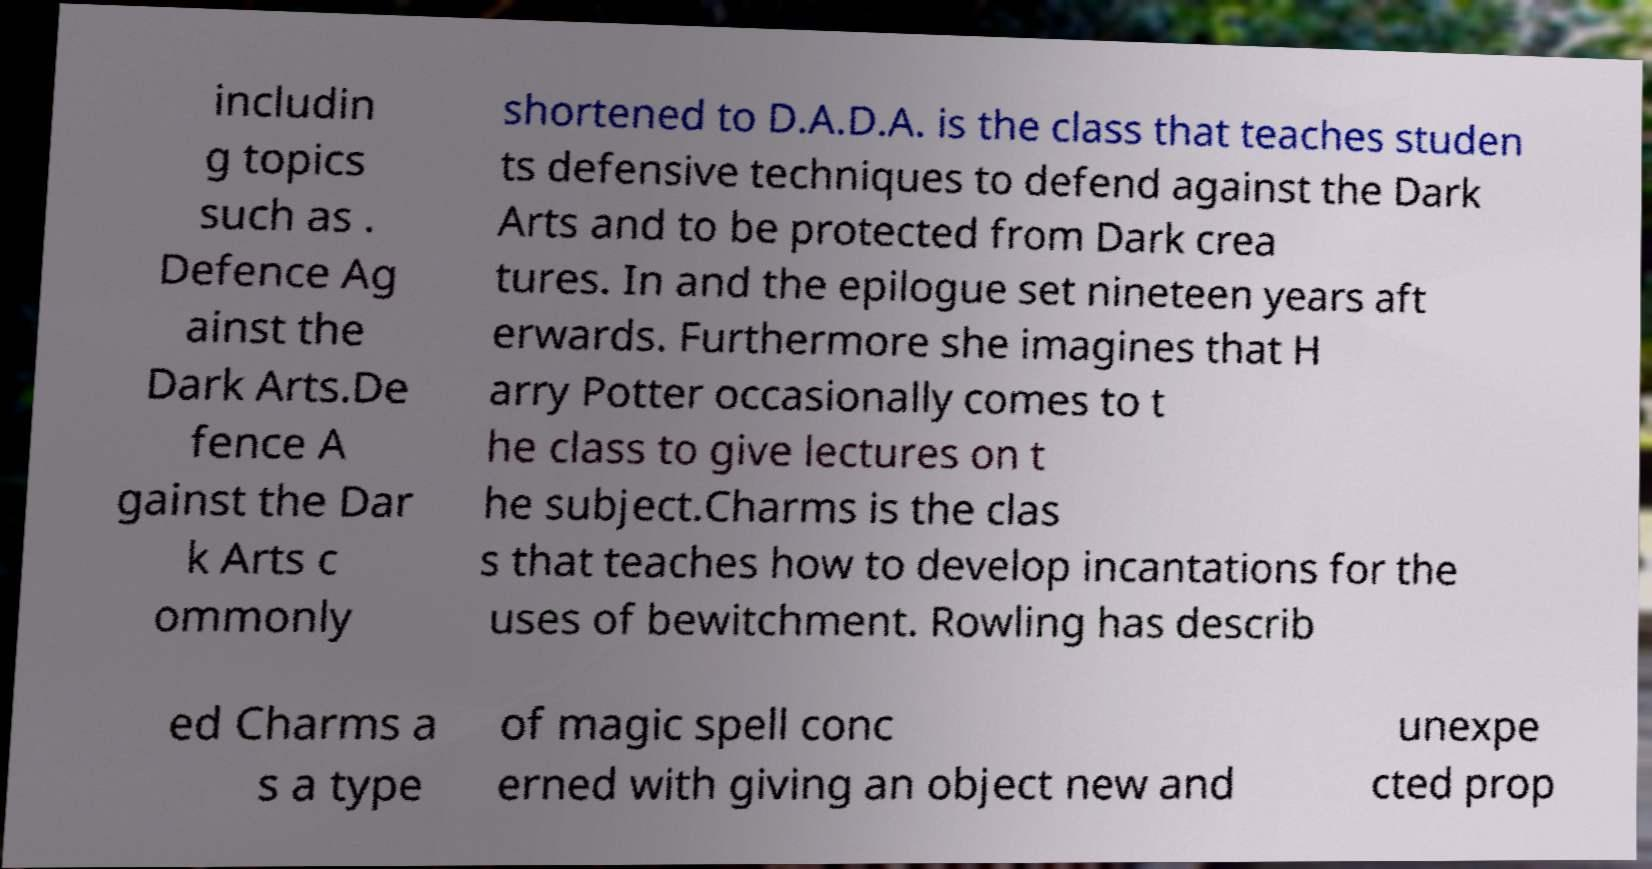Can you read and provide the text displayed in the image?This photo seems to have some interesting text. Can you extract and type it out for me? includin g topics such as . Defence Ag ainst the Dark Arts.De fence A gainst the Dar k Arts c ommonly shortened to D.A.D.A. is the class that teaches studen ts defensive techniques to defend against the Dark Arts and to be protected from Dark crea tures. In and the epilogue set nineteen years aft erwards. Furthermore she imagines that H arry Potter occasionally comes to t he class to give lectures on t he subject.Charms is the clas s that teaches how to develop incantations for the uses of bewitchment. Rowling has describ ed Charms a s a type of magic spell conc erned with giving an object new and unexpe cted prop 